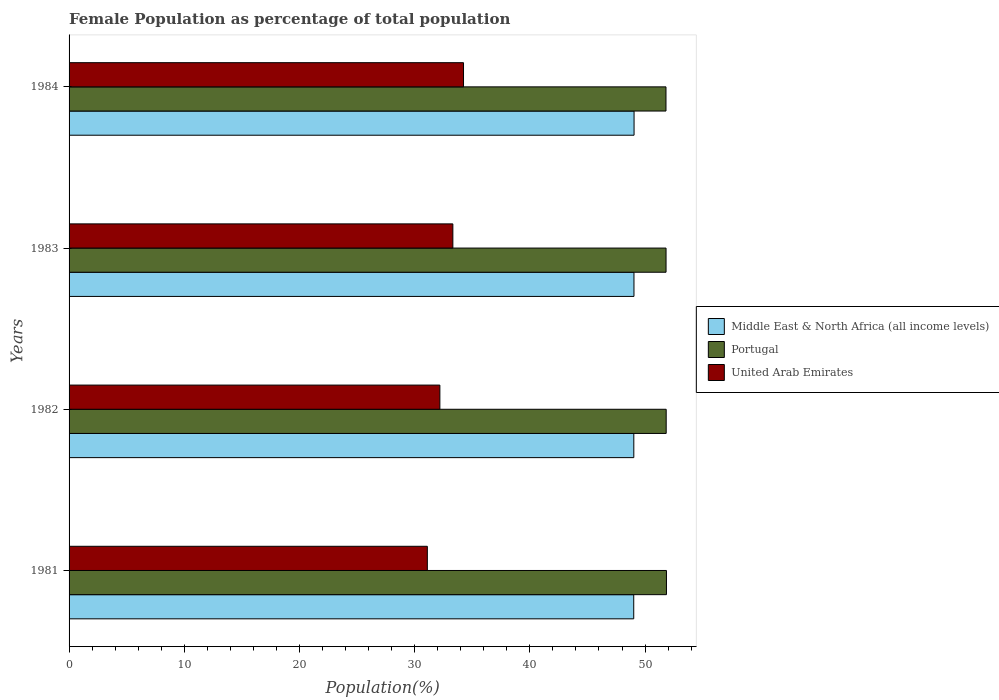How many different coloured bars are there?
Provide a succinct answer. 3. How many groups of bars are there?
Your answer should be very brief. 4. Are the number of bars on each tick of the Y-axis equal?
Offer a very short reply. Yes. How many bars are there on the 4th tick from the bottom?
Offer a terse response. 3. What is the label of the 3rd group of bars from the top?
Keep it short and to the point. 1982. What is the female population in in Portugal in 1981?
Give a very brief answer. 51.86. Across all years, what is the maximum female population in in Middle East & North Africa (all income levels)?
Your answer should be compact. 49.05. Across all years, what is the minimum female population in in Middle East & North Africa (all income levels)?
Make the answer very short. 49.02. What is the total female population in in Portugal in the graph?
Your answer should be compact. 207.34. What is the difference between the female population in in United Arab Emirates in 1982 and that in 1983?
Ensure brevity in your answer.  -1.13. What is the difference between the female population in in United Arab Emirates in 1981 and the female population in in Portugal in 1984?
Your answer should be compact. -20.72. What is the average female population in in Middle East & North Africa (all income levels) per year?
Offer a terse response. 49.03. In the year 1981, what is the difference between the female population in in Middle East & North Africa (all income levels) and female population in in Portugal?
Provide a succinct answer. -2.84. In how many years, is the female population in in Portugal greater than 46 %?
Make the answer very short. 4. What is the ratio of the female population in in Portugal in 1981 to that in 1983?
Your answer should be compact. 1. Is the female population in in Middle East & North Africa (all income levels) in 1981 less than that in 1984?
Keep it short and to the point. Yes. Is the difference between the female population in in Middle East & North Africa (all income levels) in 1982 and 1983 greater than the difference between the female population in in Portugal in 1982 and 1983?
Offer a terse response. No. What is the difference between the highest and the second highest female population in in Middle East & North Africa (all income levels)?
Ensure brevity in your answer.  0.01. What is the difference between the highest and the lowest female population in in United Arab Emirates?
Your answer should be very brief. 3.14. Is the sum of the female population in in Middle East & North Africa (all income levels) in 1982 and 1984 greater than the maximum female population in in Portugal across all years?
Keep it short and to the point. Yes. What does the 3rd bar from the top in 1981 represents?
Make the answer very short. Middle East & North Africa (all income levels). What does the 2nd bar from the bottom in 1983 represents?
Offer a terse response. Portugal. How many years are there in the graph?
Offer a terse response. 4. What is the difference between two consecutive major ticks on the X-axis?
Offer a very short reply. 10. Are the values on the major ticks of X-axis written in scientific E-notation?
Your response must be concise. No. Does the graph contain any zero values?
Ensure brevity in your answer.  No. Does the graph contain grids?
Offer a terse response. No. How many legend labels are there?
Offer a terse response. 3. What is the title of the graph?
Offer a terse response. Female Population as percentage of total population. Does "High income" appear as one of the legend labels in the graph?
Give a very brief answer. No. What is the label or title of the X-axis?
Your answer should be very brief. Population(%). What is the label or title of the Y-axis?
Provide a short and direct response. Years. What is the Population(%) in Middle East & North Africa (all income levels) in 1981?
Your response must be concise. 49.02. What is the Population(%) in Portugal in 1981?
Offer a terse response. 51.86. What is the Population(%) in United Arab Emirates in 1981?
Offer a terse response. 31.1. What is the Population(%) of Middle East & North Africa (all income levels) in 1982?
Your answer should be very brief. 49.03. What is the Population(%) of Portugal in 1982?
Provide a short and direct response. 51.84. What is the Population(%) in United Arab Emirates in 1982?
Provide a short and direct response. 32.19. What is the Population(%) in Middle East & North Africa (all income levels) in 1983?
Keep it short and to the point. 49.04. What is the Population(%) in Portugal in 1983?
Offer a very short reply. 51.82. What is the Population(%) in United Arab Emirates in 1983?
Provide a succinct answer. 33.32. What is the Population(%) of Middle East & North Africa (all income levels) in 1984?
Make the answer very short. 49.05. What is the Population(%) in Portugal in 1984?
Keep it short and to the point. 51.82. What is the Population(%) in United Arab Emirates in 1984?
Your response must be concise. 34.24. Across all years, what is the maximum Population(%) of Middle East & North Africa (all income levels)?
Your answer should be very brief. 49.05. Across all years, what is the maximum Population(%) in Portugal?
Ensure brevity in your answer.  51.86. Across all years, what is the maximum Population(%) of United Arab Emirates?
Offer a terse response. 34.24. Across all years, what is the minimum Population(%) in Middle East & North Africa (all income levels)?
Your answer should be very brief. 49.02. Across all years, what is the minimum Population(%) of Portugal?
Keep it short and to the point. 51.82. Across all years, what is the minimum Population(%) in United Arab Emirates?
Your answer should be very brief. 31.1. What is the total Population(%) of Middle East & North Africa (all income levels) in the graph?
Make the answer very short. 196.13. What is the total Population(%) in Portugal in the graph?
Your response must be concise. 207.34. What is the total Population(%) in United Arab Emirates in the graph?
Your answer should be very brief. 130.85. What is the difference between the Population(%) in Middle East & North Africa (all income levels) in 1981 and that in 1982?
Your answer should be very brief. -0.01. What is the difference between the Population(%) in Portugal in 1981 and that in 1982?
Offer a very short reply. 0.02. What is the difference between the Population(%) of United Arab Emirates in 1981 and that in 1982?
Offer a very short reply. -1.09. What is the difference between the Population(%) in Middle East & North Africa (all income levels) in 1981 and that in 1983?
Your response must be concise. -0.02. What is the difference between the Population(%) of Portugal in 1981 and that in 1983?
Your answer should be very brief. 0.04. What is the difference between the Population(%) in United Arab Emirates in 1981 and that in 1983?
Your answer should be very brief. -2.22. What is the difference between the Population(%) in Middle East & North Africa (all income levels) in 1981 and that in 1984?
Provide a succinct answer. -0.03. What is the difference between the Population(%) of Portugal in 1981 and that in 1984?
Your answer should be very brief. 0.04. What is the difference between the Population(%) in United Arab Emirates in 1981 and that in 1984?
Make the answer very short. -3.14. What is the difference between the Population(%) in Middle East & North Africa (all income levels) in 1982 and that in 1983?
Make the answer very short. -0.01. What is the difference between the Population(%) in Portugal in 1982 and that in 1983?
Your answer should be very brief. 0.01. What is the difference between the Population(%) in United Arab Emirates in 1982 and that in 1983?
Give a very brief answer. -1.13. What is the difference between the Population(%) of Middle East & North Africa (all income levels) in 1982 and that in 1984?
Keep it short and to the point. -0.02. What is the difference between the Population(%) of Portugal in 1982 and that in 1984?
Your answer should be compact. 0.02. What is the difference between the Population(%) in United Arab Emirates in 1982 and that in 1984?
Offer a very short reply. -2.05. What is the difference between the Population(%) of Middle East & North Africa (all income levels) in 1983 and that in 1984?
Make the answer very short. -0.01. What is the difference between the Population(%) of Portugal in 1983 and that in 1984?
Provide a succinct answer. 0.01. What is the difference between the Population(%) in United Arab Emirates in 1983 and that in 1984?
Give a very brief answer. -0.92. What is the difference between the Population(%) of Middle East & North Africa (all income levels) in 1981 and the Population(%) of Portugal in 1982?
Ensure brevity in your answer.  -2.82. What is the difference between the Population(%) in Middle East & North Africa (all income levels) in 1981 and the Population(%) in United Arab Emirates in 1982?
Keep it short and to the point. 16.83. What is the difference between the Population(%) of Portugal in 1981 and the Population(%) of United Arab Emirates in 1982?
Provide a short and direct response. 19.67. What is the difference between the Population(%) in Middle East & North Africa (all income levels) in 1981 and the Population(%) in Portugal in 1983?
Provide a succinct answer. -2.81. What is the difference between the Population(%) in Middle East & North Africa (all income levels) in 1981 and the Population(%) in United Arab Emirates in 1983?
Your answer should be very brief. 15.7. What is the difference between the Population(%) in Portugal in 1981 and the Population(%) in United Arab Emirates in 1983?
Keep it short and to the point. 18.54. What is the difference between the Population(%) in Middle East & North Africa (all income levels) in 1981 and the Population(%) in Portugal in 1984?
Make the answer very short. -2.8. What is the difference between the Population(%) in Middle East & North Africa (all income levels) in 1981 and the Population(%) in United Arab Emirates in 1984?
Ensure brevity in your answer.  14.78. What is the difference between the Population(%) of Portugal in 1981 and the Population(%) of United Arab Emirates in 1984?
Make the answer very short. 17.62. What is the difference between the Population(%) of Middle East & North Africa (all income levels) in 1982 and the Population(%) of Portugal in 1983?
Your answer should be compact. -2.8. What is the difference between the Population(%) in Middle East & North Africa (all income levels) in 1982 and the Population(%) in United Arab Emirates in 1983?
Your answer should be very brief. 15.71. What is the difference between the Population(%) in Portugal in 1982 and the Population(%) in United Arab Emirates in 1983?
Provide a succinct answer. 18.52. What is the difference between the Population(%) of Middle East & North Africa (all income levels) in 1982 and the Population(%) of Portugal in 1984?
Your answer should be very brief. -2.79. What is the difference between the Population(%) of Middle East & North Africa (all income levels) in 1982 and the Population(%) of United Arab Emirates in 1984?
Ensure brevity in your answer.  14.78. What is the difference between the Population(%) in Portugal in 1982 and the Population(%) in United Arab Emirates in 1984?
Offer a terse response. 17.59. What is the difference between the Population(%) in Middle East & North Africa (all income levels) in 1983 and the Population(%) in Portugal in 1984?
Provide a succinct answer. -2.78. What is the difference between the Population(%) of Middle East & North Africa (all income levels) in 1983 and the Population(%) of United Arab Emirates in 1984?
Keep it short and to the point. 14.8. What is the difference between the Population(%) in Portugal in 1983 and the Population(%) in United Arab Emirates in 1984?
Offer a very short reply. 17.58. What is the average Population(%) in Middle East & North Africa (all income levels) per year?
Offer a terse response. 49.03. What is the average Population(%) in Portugal per year?
Ensure brevity in your answer.  51.83. What is the average Population(%) of United Arab Emirates per year?
Provide a short and direct response. 32.71. In the year 1981, what is the difference between the Population(%) in Middle East & North Africa (all income levels) and Population(%) in Portugal?
Your answer should be very brief. -2.84. In the year 1981, what is the difference between the Population(%) of Middle East & North Africa (all income levels) and Population(%) of United Arab Emirates?
Make the answer very short. 17.92. In the year 1981, what is the difference between the Population(%) in Portugal and Population(%) in United Arab Emirates?
Make the answer very short. 20.76. In the year 1982, what is the difference between the Population(%) in Middle East & North Africa (all income levels) and Population(%) in Portugal?
Your answer should be very brief. -2.81. In the year 1982, what is the difference between the Population(%) in Middle East & North Africa (all income levels) and Population(%) in United Arab Emirates?
Make the answer very short. 16.84. In the year 1982, what is the difference between the Population(%) in Portugal and Population(%) in United Arab Emirates?
Your answer should be compact. 19.65. In the year 1983, what is the difference between the Population(%) of Middle East & North Africa (all income levels) and Population(%) of Portugal?
Provide a succinct answer. -2.79. In the year 1983, what is the difference between the Population(%) of Middle East & North Africa (all income levels) and Population(%) of United Arab Emirates?
Make the answer very short. 15.72. In the year 1983, what is the difference between the Population(%) of Portugal and Population(%) of United Arab Emirates?
Your answer should be very brief. 18.51. In the year 1984, what is the difference between the Population(%) in Middle East & North Africa (all income levels) and Population(%) in Portugal?
Make the answer very short. -2.77. In the year 1984, what is the difference between the Population(%) of Middle East & North Africa (all income levels) and Population(%) of United Arab Emirates?
Provide a short and direct response. 14.81. In the year 1984, what is the difference between the Population(%) in Portugal and Population(%) in United Arab Emirates?
Make the answer very short. 17.58. What is the ratio of the Population(%) in United Arab Emirates in 1981 to that in 1982?
Give a very brief answer. 0.97. What is the ratio of the Population(%) in Middle East & North Africa (all income levels) in 1981 to that in 1983?
Your response must be concise. 1. What is the ratio of the Population(%) in Portugal in 1981 to that in 1983?
Give a very brief answer. 1. What is the ratio of the Population(%) of United Arab Emirates in 1981 to that in 1983?
Ensure brevity in your answer.  0.93. What is the ratio of the Population(%) in Middle East & North Africa (all income levels) in 1981 to that in 1984?
Offer a very short reply. 1. What is the ratio of the Population(%) in Portugal in 1981 to that in 1984?
Your answer should be very brief. 1. What is the ratio of the Population(%) in United Arab Emirates in 1981 to that in 1984?
Your answer should be compact. 0.91. What is the ratio of the Population(%) in United Arab Emirates in 1982 to that in 1983?
Keep it short and to the point. 0.97. What is the ratio of the Population(%) of Portugal in 1982 to that in 1984?
Your answer should be compact. 1. What is the ratio of the Population(%) of United Arab Emirates in 1982 to that in 1984?
Keep it short and to the point. 0.94. What is the ratio of the Population(%) in Middle East & North Africa (all income levels) in 1983 to that in 1984?
Offer a very short reply. 1. What is the ratio of the Population(%) of United Arab Emirates in 1983 to that in 1984?
Make the answer very short. 0.97. What is the difference between the highest and the second highest Population(%) in Middle East & North Africa (all income levels)?
Offer a very short reply. 0.01. What is the difference between the highest and the second highest Population(%) of Portugal?
Give a very brief answer. 0.02. What is the difference between the highest and the second highest Population(%) of United Arab Emirates?
Your response must be concise. 0.92. What is the difference between the highest and the lowest Population(%) in Middle East & North Africa (all income levels)?
Keep it short and to the point. 0.03. What is the difference between the highest and the lowest Population(%) of Portugal?
Offer a terse response. 0.04. What is the difference between the highest and the lowest Population(%) of United Arab Emirates?
Offer a very short reply. 3.14. 